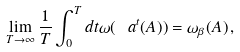<formula> <loc_0><loc_0><loc_500><loc_500>\lim _ { T \rightarrow \infty } \frac { 1 } { T } \int _ { 0 } ^ { T } d t \omega ( \ a ^ { t } ( A ) ) = \omega _ { \beta } ( A ) \, ,</formula> 